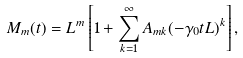Convert formula to latex. <formula><loc_0><loc_0><loc_500><loc_500>M _ { m } ( t ) = L ^ { m } \left [ 1 + \sum _ { k = 1 } ^ { \infty } A _ { m k } ( - \gamma _ { 0 } t L ) ^ { k } \right ] ,</formula> 